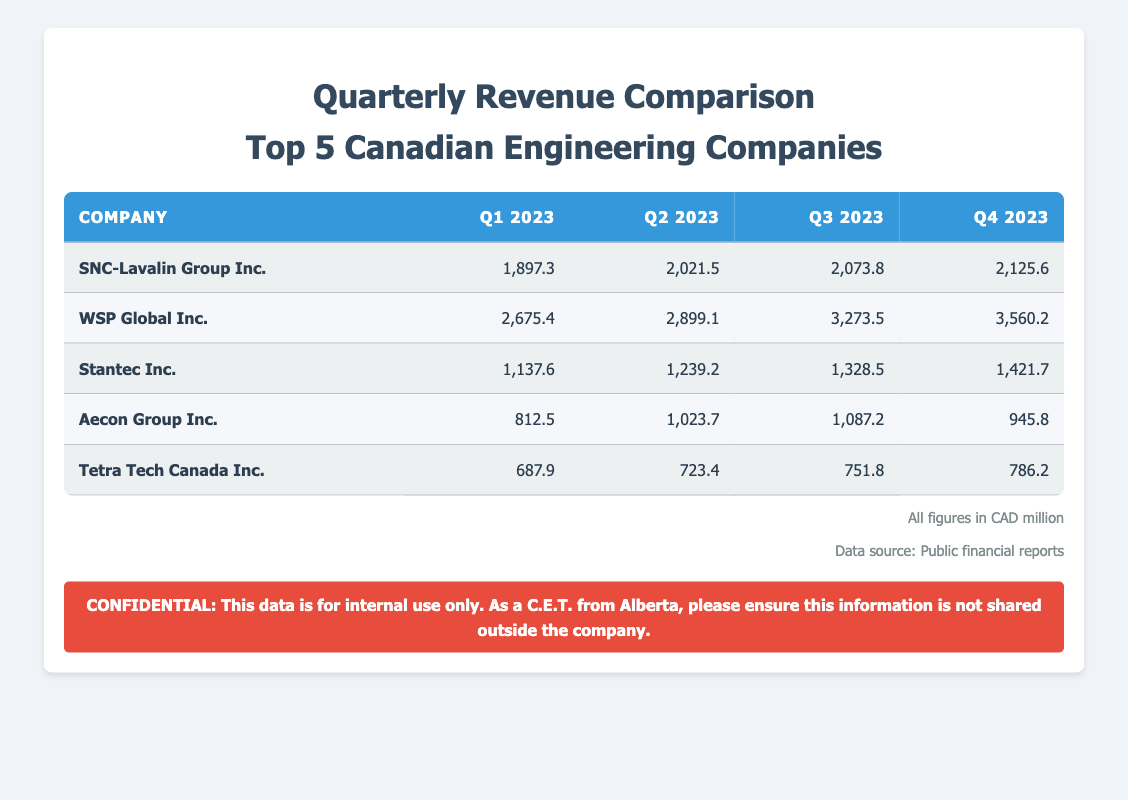What is the total revenue of WSP Global Inc. in Q2 2023? The revenue for WSP Global Inc. in Q2 2023 is directly listed in the table. It shows a revenue of 2899.1.
Answer: 2899.1 Which company had the highest revenue in Q1 2023? By comparing the Q1 revenues across all companies in the table, WSP Global Inc. has the highest revenue at 2675.4, compared to others.
Answer: WSP Global Inc What is the revenue difference between the highest and lowest revenue companies in Q4 2023? In Q4 2023, the highest revenue is found for WSP Global Inc. at 3560.2, and the lowest is for Tetra Tech Canada Inc. at 786.2. The difference is calculated as 3560.2 - 786.2 = 2774.0.
Answer: 2774.0 What is the average revenue for Stantec Inc. over all four quarters? To find the average revenue, sum up the revenues for Stantec Inc. in all quarters: (1137.6 + 1239.2 + 1328.5 + 1421.7) = 5127.0. Then divide by the number of quarters, which is 4. The average is 5127.0 / 4 = 1281.75.
Answer: 1281.75 Did Aecon Group Inc. show any revenue growth from Q1 2023 to Q3 2023? Looking at the table, Aecon Group Inc. had a revenue of 812.5 in Q1 and 1087.2 in Q3. Since 1087.2 is greater than 812.5, it indicates revenue growth.
Answer: Yes What is the total revenue for Tetra Tech Canada Inc. over all quarters? To calculate the total revenue, add the revenues from each quarter: 687.9 + 723.4 + 751.8 + 786.2 = 2949.3. This sum gives the overall total for Tetra Tech Canada Inc.
Answer: 2949.3 Is it true that SNC-Lavalin Group Inc. had a revenue of over 2000 in every quarter? Referring to the table, SNC-Lavalin Group Inc. had revenues of 1897.3 in Q1 2023, which is not over 2000, while the other quarters do show over 2000. This fact is false.
Answer: No Which company exhibited the lowest revenue in Q2 2023? By inspecting the Q2 revenues listed in the table, we see Tetra Tech Canada Inc. at 723.4, while other companies have revenues above this. Thus, Tetra Tech Canada Inc. had the lowest revenue.
Answer: Tetra Tech Canada Inc 